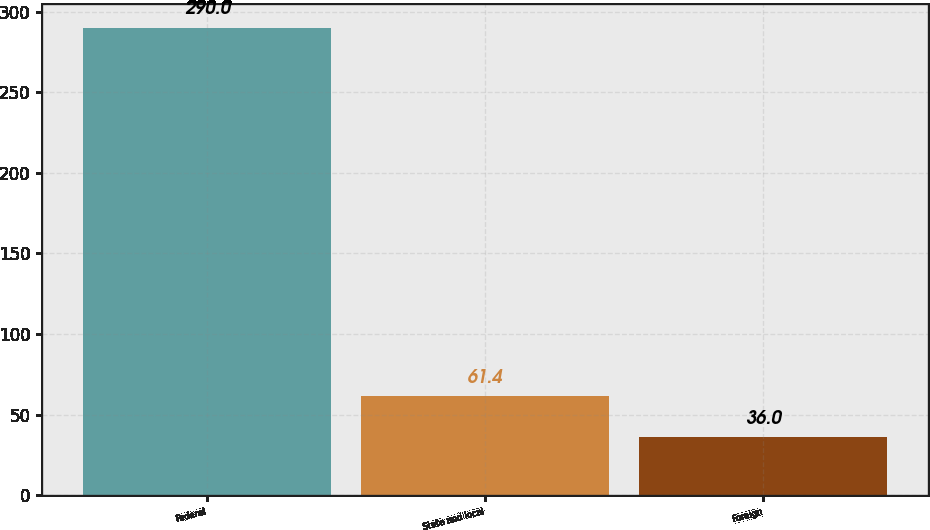<chart> <loc_0><loc_0><loc_500><loc_500><bar_chart><fcel>Federal<fcel>State and local<fcel>Foreign<nl><fcel>290<fcel>61.4<fcel>36<nl></chart> 